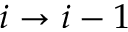Convert formula to latex. <formula><loc_0><loc_0><loc_500><loc_500>i \to i - 1</formula> 